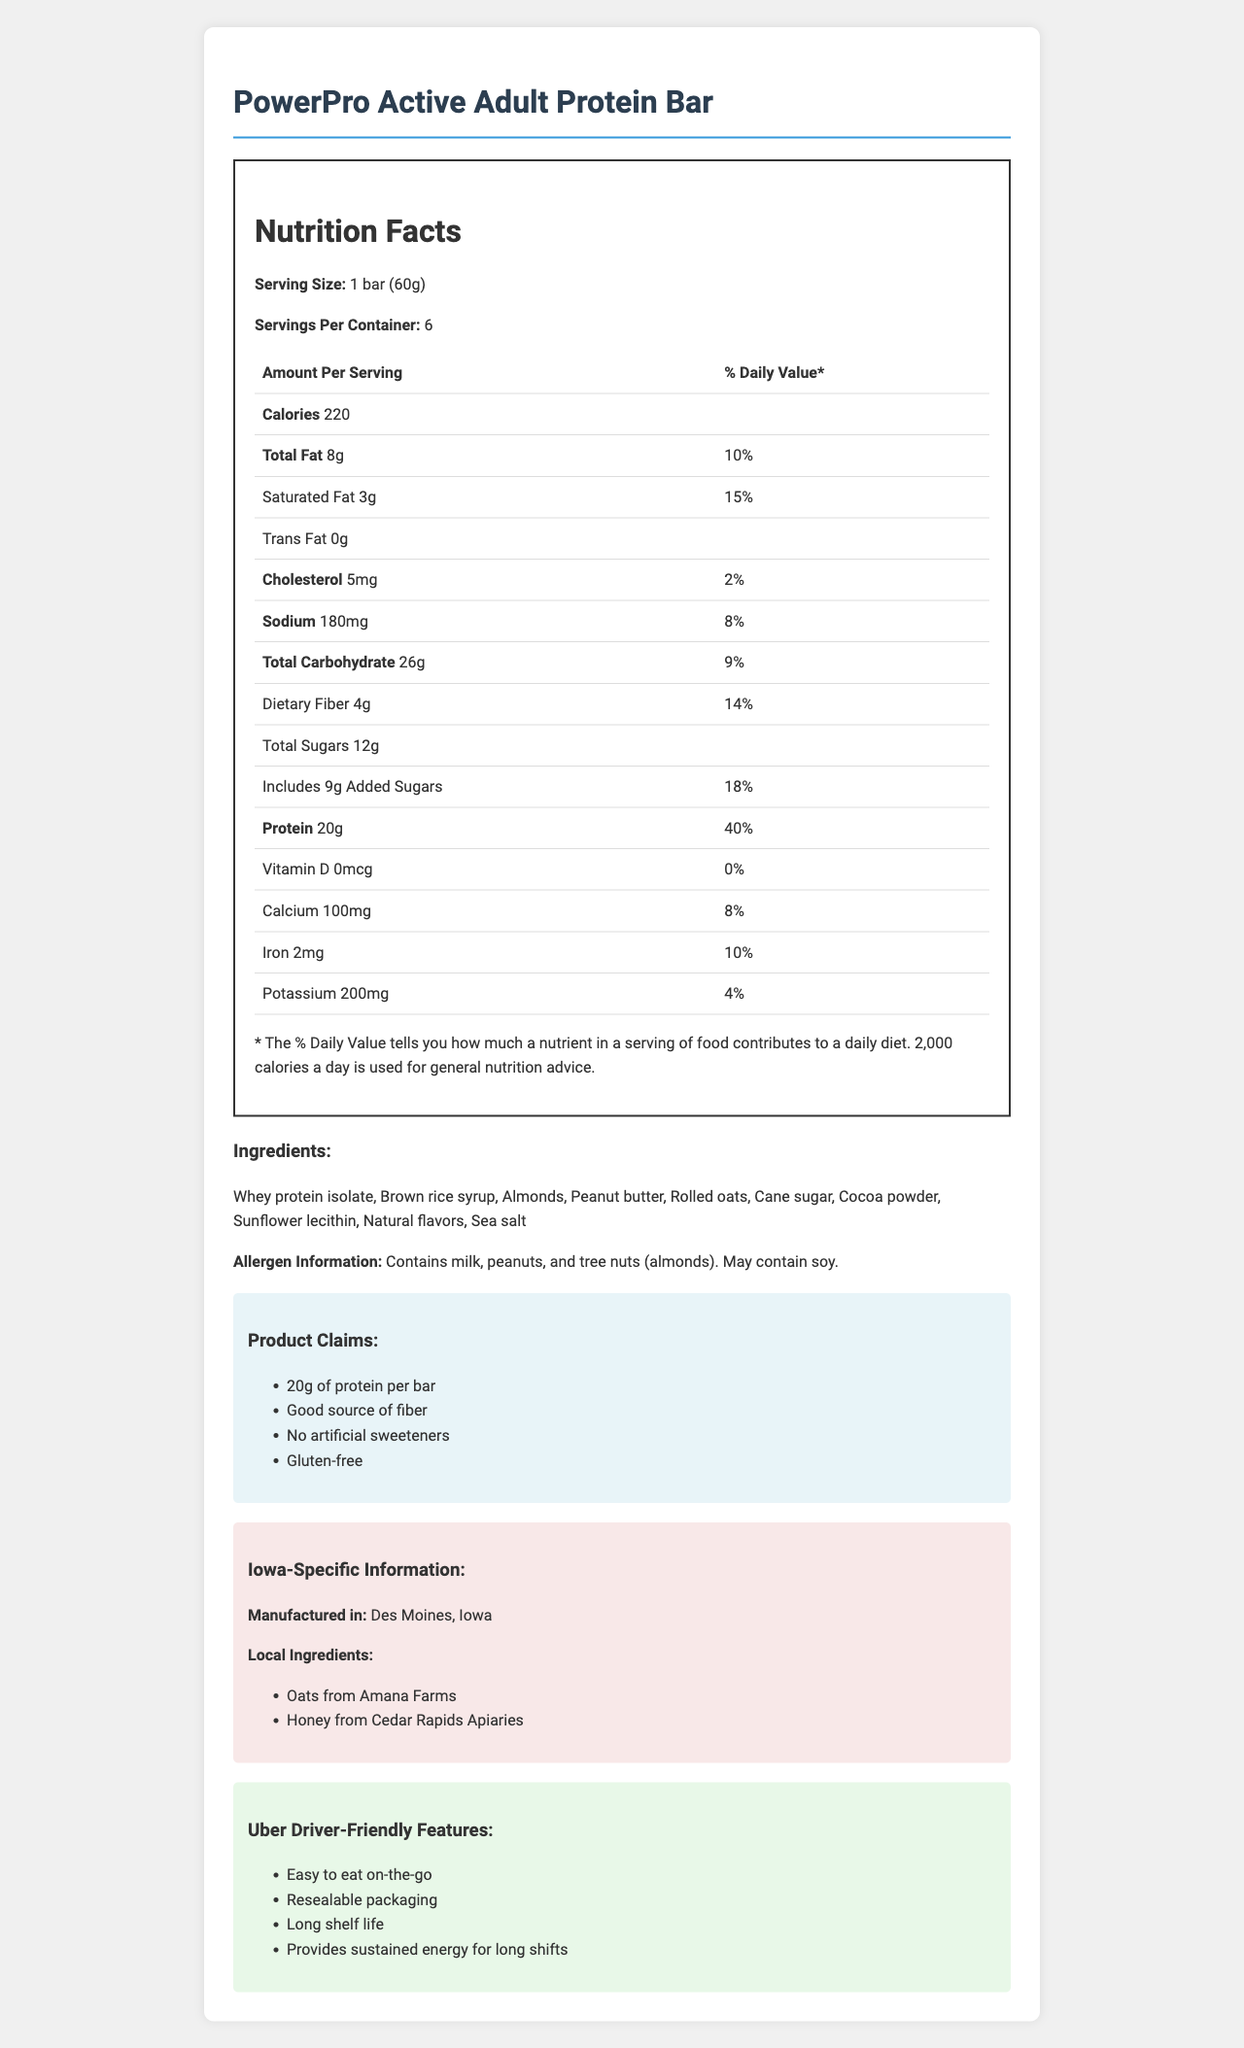What is the serving size of the PowerPro Active Adult Protein Bar? The document states in the Nutrition Facts section that the serving size is "1 bar (60g)".
Answer: 1 bar (60g) How many calories are in each serving? Under the Nutrition Facts section, the document states that each serving (1 bar) contains 220 calories.
Answer: 220 How much protein is in each bar, and what percentage of the daily value does it represent? The document lists "Protein: 20g" and "Daily Value: 40%" under the Nutrition Facts label for each serving.
Answer: 20g, 40% Which local ingredients are used in the PowerPro Active Adult Protein Bar? The Iowa-specific information section lists "Oats from Amana Farms" and "Honey from Cedar Rapids Apiaries" as local ingredients.
Answer: Oats from Amana Farms, Honey from Cedar Rapids Apiaries What allergens are present in the PowerPro Active Adult Protein Bar? The ingredients section specifies that the bar contains milk, peanuts, and tree nuts (almonds) and may contain soy.
Answer: Milk, peanuts, and tree nuts (almonds). May contain soy. What is the total fat content per serving, and what percentage of the daily value does this represent? The Nutrition Facts section shows "Total Fat: 8g" and "Daily Value: 10%."
Answer: 8g, 10% How much added sugar is in each serving? According to the Nutrition Facts, each serving includes 9g of added sugars.
Answer: 9g Which of the following claims is NOT made about the product? A. Good source of vitamin D B. 20g of protein per bar C. Gluten-free The claims section lists 20g of protein per bar and gluten-free as features but does not mention being a good source of vitamin D.
Answer: A. Good source of vitamin D Where is the PowerPro Active Adult Protein Bar manufactured? A. Cedar Rapids, Iowa B. Des Moines, Iowa C. Amana, Iowa The Iowa-specific information section states that the bar is manufactured in Des Moines, Iowa.
Answer: B. Des Moines, Iowa Is the PowerPro Active Adult Protein Bar gluten-free? One of the product claims listed in the claims section is "Gluten-free."
Answer: Yes Does the PowerPro Active Adult Protein Bar contain artificial sweeteners? The claims section includes "No artificial sweeteners" as one of the product features.
Answer: No What features make the PowerPro Active Adult Protein Bar friendly for Uber drivers? The Uber driver-friendly features section lists these specific attributes.
Answer: Easy to eat on-the-go, resealable packaging, long shelf life, provides sustained energy for long shifts How much vitamin D is in each serving of the protein bar? The Nutrition Facts state that each serving contains 0mcg of vitamin D and 0% of the daily value.
Answer: 0mcg, 0% Summarize the main features and nutritional information of the PowerPro Active Adult Protein Bar. The document provides a comprehensive look at the nutritional information, ingredients, claims, local connections, and features that are beneficial for Uber drivers.
Answer: The PowerPro Active Adult Protein Bar is designed for active adults and Uber drivers. Each bar (60g) contains 220 calories, 8g of total fat (10% DV), 3g of saturated fat (15% DV), 0g trans fat, 5mg cholesterol (2% DV), 180mg sodium (8% DV), 26g total carbohydrates (9% DV), 4g dietary fiber (14% DV), 12g total sugars, 9g added sugars (18% DV), and 20g protein (40% DV). It is gluten-free, made with local Iowa ingredients, and does not contain artificial sweeteners. It is manufactured in Des Moines, Iowa. How long is the shelf life of the PowerPro Active Adult Protein Bar? The exact shelf life duration is not specified in the document.
Answer: Not enough information What is the percentage daily value of iron in each serving? The Nutrition Facts list iron as having a daily value of 10% per serving.
Answer: 10% 